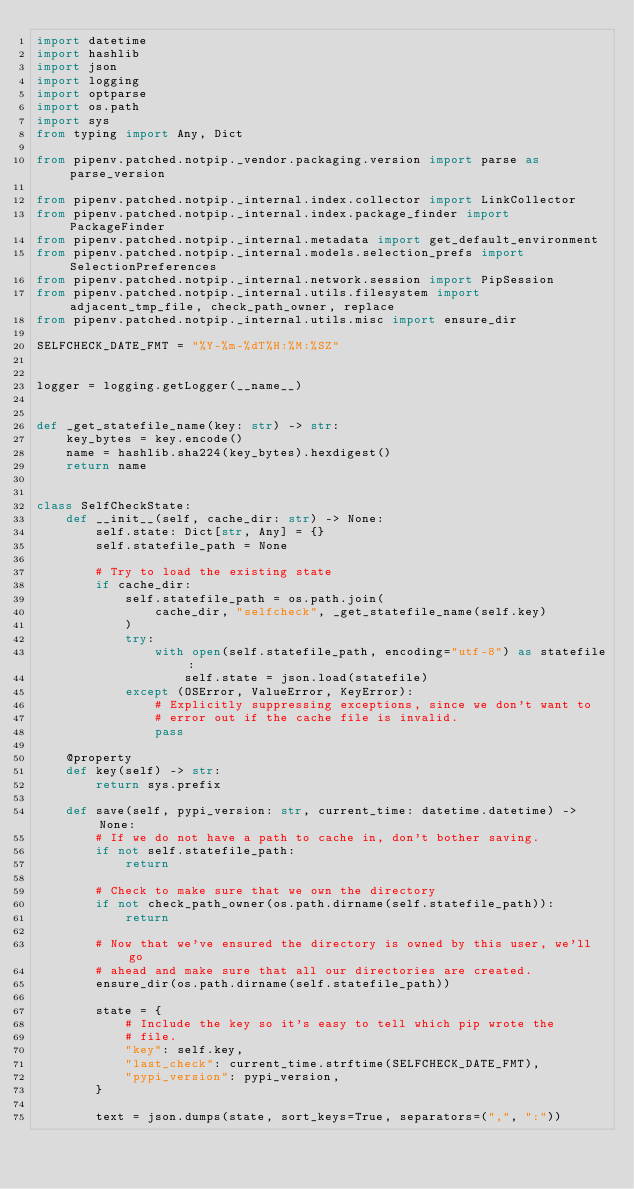<code> <loc_0><loc_0><loc_500><loc_500><_Python_>import datetime
import hashlib
import json
import logging
import optparse
import os.path
import sys
from typing import Any, Dict

from pipenv.patched.notpip._vendor.packaging.version import parse as parse_version

from pipenv.patched.notpip._internal.index.collector import LinkCollector
from pipenv.patched.notpip._internal.index.package_finder import PackageFinder
from pipenv.patched.notpip._internal.metadata import get_default_environment
from pipenv.patched.notpip._internal.models.selection_prefs import SelectionPreferences
from pipenv.patched.notpip._internal.network.session import PipSession
from pipenv.patched.notpip._internal.utils.filesystem import adjacent_tmp_file, check_path_owner, replace
from pipenv.patched.notpip._internal.utils.misc import ensure_dir

SELFCHECK_DATE_FMT = "%Y-%m-%dT%H:%M:%SZ"


logger = logging.getLogger(__name__)


def _get_statefile_name(key: str) -> str:
    key_bytes = key.encode()
    name = hashlib.sha224(key_bytes).hexdigest()
    return name


class SelfCheckState:
    def __init__(self, cache_dir: str) -> None:
        self.state: Dict[str, Any] = {}
        self.statefile_path = None

        # Try to load the existing state
        if cache_dir:
            self.statefile_path = os.path.join(
                cache_dir, "selfcheck", _get_statefile_name(self.key)
            )
            try:
                with open(self.statefile_path, encoding="utf-8") as statefile:
                    self.state = json.load(statefile)
            except (OSError, ValueError, KeyError):
                # Explicitly suppressing exceptions, since we don't want to
                # error out if the cache file is invalid.
                pass

    @property
    def key(self) -> str:
        return sys.prefix

    def save(self, pypi_version: str, current_time: datetime.datetime) -> None:
        # If we do not have a path to cache in, don't bother saving.
        if not self.statefile_path:
            return

        # Check to make sure that we own the directory
        if not check_path_owner(os.path.dirname(self.statefile_path)):
            return

        # Now that we've ensured the directory is owned by this user, we'll go
        # ahead and make sure that all our directories are created.
        ensure_dir(os.path.dirname(self.statefile_path))

        state = {
            # Include the key so it's easy to tell which pip wrote the
            # file.
            "key": self.key,
            "last_check": current_time.strftime(SELFCHECK_DATE_FMT),
            "pypi_version": pypi_version,
        }

        text = json.dumps(state, sort_keys=True, separators=(",", ":"))
</code> 